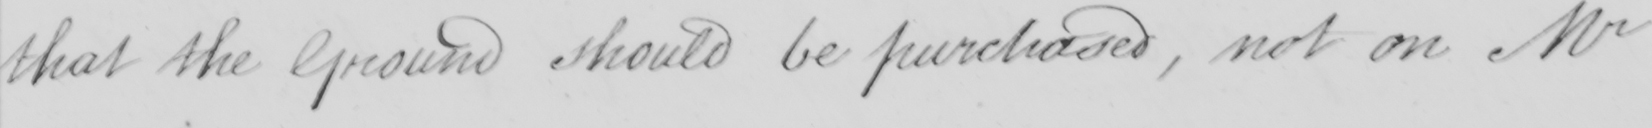Please transcribe the handwritten text in this image. that the Ground should be purchased, not on Mr 